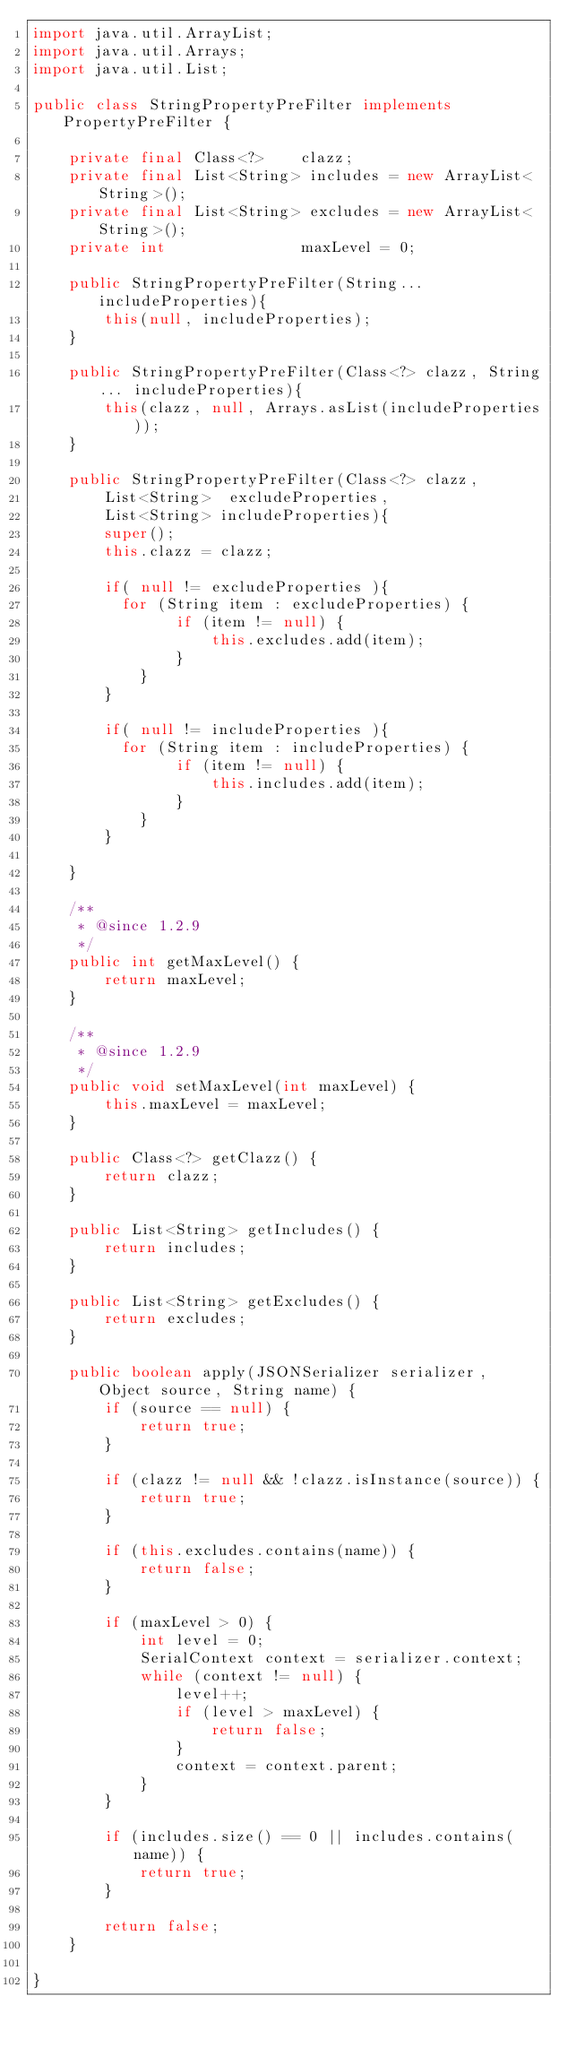Convert code to text. <code><loc_0><loc_0><loc_500><loc_500><_Java_>import java.util.ArrayList;
import java.util.Arrays;
import java.util.List;

public class StringPropertyPreFilter implements PropertyPreFilter {

    private final Class<?>    clazz;
    private final List<String> includes = new ArrayList<String>();
    private final List<String> excludes = new ArrayList<String>();
    private int               maxLevel = 0;

    public StringPropertyPreFilter(String... includeProperties){
        this(null, includeProperties);
    }

    public StringPropertyPreFilter(Class<?> clazz, String... includeProperties){
        this(clazz, null, Arrays.asList(includeProperties));
    }
    
    public StringPropertyPreFilter(Class<?> clazz, 
    		List<String>  excludeProperties,
    		List<String> includeProperties){
        super();
        this.clazz = clazz;
        
        if( null != excludeProperties ){
        	for (String item : excludeProperties) {
                if (item != null) {
                    this.excludes.add(item);
                }
            }
        }
        
        if( null != includeProperties ){
        	for (String item : includeProperties) {
                if (item != null) {
                    this.includes.add(item);
                }
            }
        }
        
    }
    
    /**
     * @since 1.2.9
     */
    public int getMaxLevel() {
        return maxLevel;
    }
    
    /**
     * @since 1.2.9
     */
    public void setMaxLevel(int maxLevel) {
        this.maxLevel = maxLevel;
    }

    public Class<?> getClazz() {
        return clazz;
    }

    public List<String> getIncludes() {
        return includes;
    }

    public List<String> getExcludes() {
        return excludes;
    }

    public boolean apply(JSONSerializer serializer, Object source, String name) {
        if (source == null) {
            return true;
        }

        if (clazz != null && !clazz.isInstance(source)) {
            return true;
        }

        if (this.excludes.contains(name)) {
            return false;
        }
        
        if (maxLevel > 0) {
            int level = 0;
            SerialContext context = serializer.context;
            while (context != null) {
                level++;
                if (level > maxLevel) {
                    return false;
                }
                context = context.parent;
            }
        }

        if (includes.size() == 0 || includes.contains(name)) {
            return true;
        }
        
        return false;
    }

}
</code> 